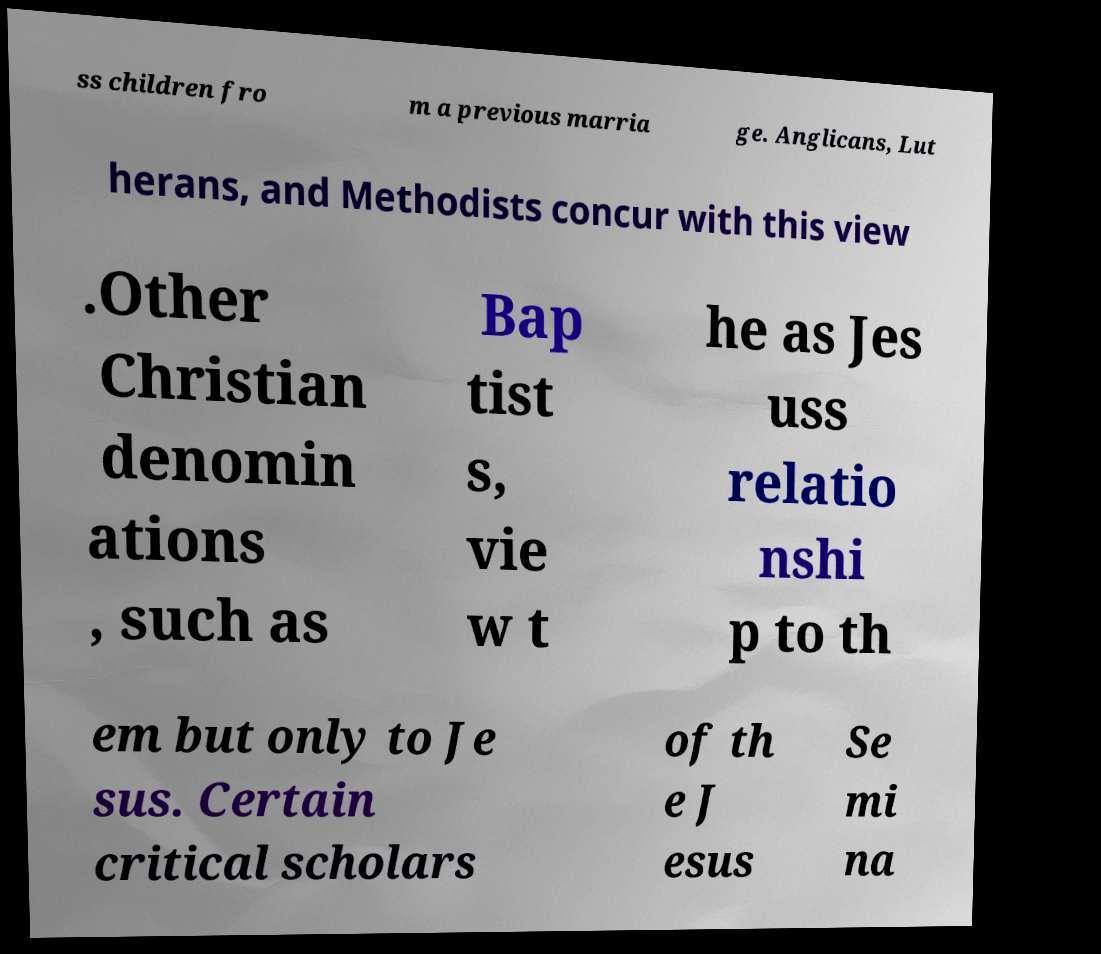I need the written content from this picture converted into text. Can you do that? ss children fro m a previous marria ge. Anglicans, Lut herans, and Methodists concur with this view .Other Christian denomin ations , such as Bap tist s, vie w t he as Jes uss relatio nshi p to th em but only to Je sus. Certain critical scholars of th e J esus Se mi na 